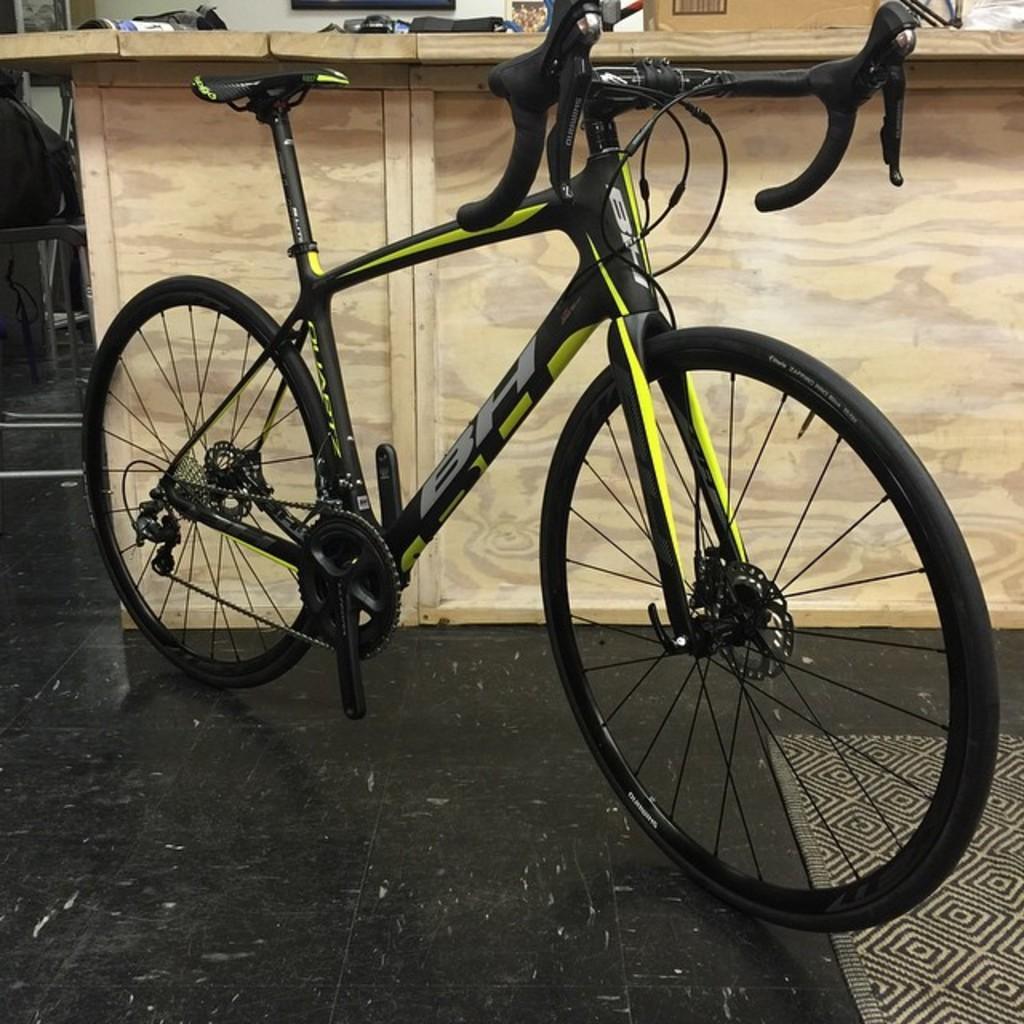Could you give a brief overview of what you see in this image? In this image there is a bicycle on the floor. Behind there is a table having a cardboard box and few objects on it. Left side there is a table having a bag on it. Background there is a wall having few frames attached to it. 